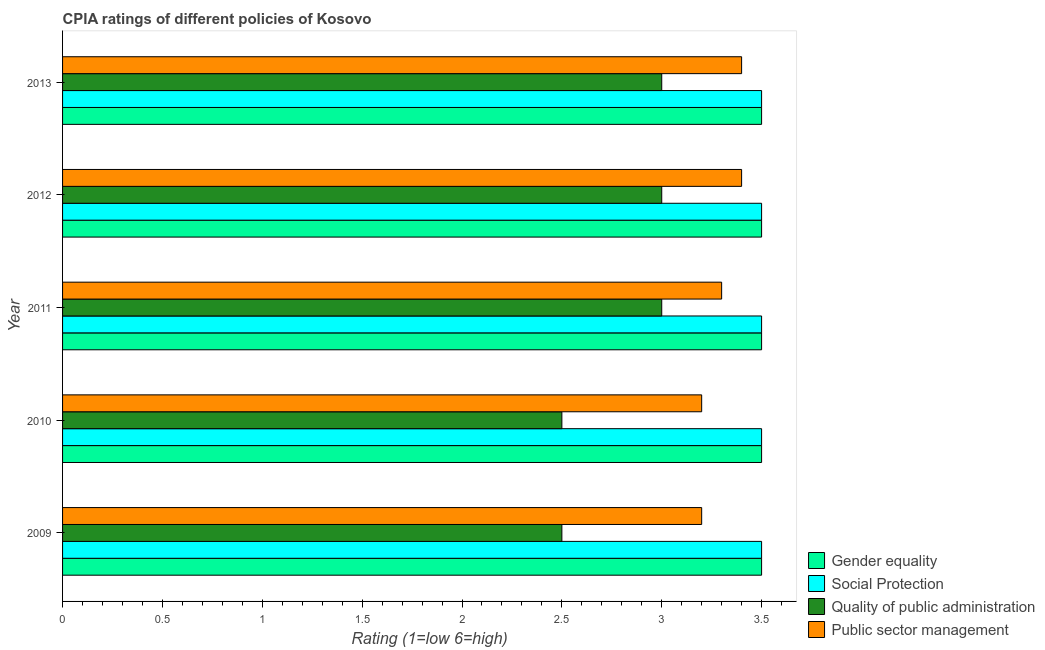How many different coloured bars are there?
Ensure brevity in your answer.  4. Are the number of bars on each tick of the Y-axis equal?
Offer a very short reply. Yes. How many bars are there on the 2nd tick from the top?
Make the answer very short. 4. What is the label of the 1st group of bars from the top?
Offer a very short reply. 2013. In how many cases, is the number of bars for a given year not equal to the number of legend labels?
Give a very brief answer. 0. In which year was the cpia rating of public sector management maximum?
Your answer should be compact. 2012. In which year was the cpia rating of gender equality minimum?
Provide a succinct answer. 2009. What is the difference between the cpia rating of social protection in 2010 and that in 2012?
Offer a very short reply. 0. What is the difference between the cpia rating of public sector management in 2010 and the cpia rating of gender equality in 2011?
Your answer should be very brief. -0.3. In how many years, is the cpia rating of public sector management greater than 0.8 ?
Keep it short and to the point. 5. Is the cpia rating of social protection in 2010 less than that in 2011?
Provide a short and direct response. No. Is the difference between the cpia rating of public sector management in 2009 and 2013 greater than the difference between the cpia rating of quality of public administration in 2009 and 2013?
Your answer should be compact. Yes. What is the difference between the highest and the second highest cpia rating of public sector management?
Your answer should be compact. 0. What is the difference between the highest and the lowest cpia rating of quality of public administration?
Make the answer very short. 0.5. Is the sum of the cpia rating of quality of public administration in 2009 and 2013 greater than the maximum cpia rating of gender equality across all years?
Ensure brevity in your answer.  Yes. What does the 3rd bar from the top in 2011 represents?
Your answer should be very brief. Social Protection. What does the 1st bar from the bottom in 2011 represents?
Make the answer very short. Gender equality. How many bars are there?
Your response must be concise. 20. How many years are there in the graph?
Provide a short and direct response. 5. Does the graph contain any zero values?
Give a very brief answer. No. How are the legend labels stacked?
Your response must be concise. Vertical. What is the title of the graph?
Your answer should be very brief. CPIA ratings of different policies of Kosovo. Does "Korea" appear as one of the legend labels in the graph?
Your answer should be very brief. No. What is the label or title of the X-axis?
Provide a succinct answer. Rating (1=low 6=high). What is the label or title of the Y-axis?
Offer a terse response. Year. What is the Rating (1=low 6=high) in Quality of public administration in 2009?
Make the answer very short. 2.5. What is the Rating (1=low 6=high) in Public sector management in 2009?
Your answer should be very brief. 3.2. What is the Rating (1=low 6=high) of Gender equality in 2010?
Provide a succinct answer. 3.5. What is the Rating (1=low 6=high) in Social Protection in 2010?
Your answer should be very brief. 3.5. What is the Rating (1=low 6=high) in Quality of public administration in 2010?
Your answer should be compact. 2.5. What is the Rating (1=low 6=high) in Public sector management in 2011?
Your answer should be very brief. 3.3. What is the Rating (1=low 6=high) in Social Protection in 2012?
Make the answer very short. 3.5. What is the Rating (1=low 6=high) of Gender equality in 2013?
Provide a succinct answer. 3.5. What is the Rating (1=low 6=high) of Quality of public administration in 2013?
Keep it short and to the point. 3. Across all years, what is the maximum Rating (1=low 6=high) of Social Protection?
Your response must be concise. 3.5. Across all years, what is the minimum Rating (1=low 6=high) in Gender equality?
Your answer should be compact. 3.5. Across all years, what is the minimum Rating (1=low 6=high) of Social Protection?
Your answer should be very brief. 3.5. What is the total Rating (1=low 6=high) in Gender equality in the graph?
Keep it short and to the point. 17.5. What is the total Rating (1=low 6=high) in Quality of public administration in the graph?
Your response must be concise. 14. What is the total Rating (1=low 6=high) in Public sector management in the graph?
Ensure brevity in your answer.  16.5. What is the difference between the Rating (1=low 6=high) of Social Protection in 2009 and that in 2010?
Offer a very short reply. 0. What is the difference between the Rating (1=low 6=high) in Gender equality in 2009 and that in 2011?
Keep it short and to the point. 0. What is the difference between the Rating (1=low 6=high) in Social Protection in 2009 and that in 2011?
Your answer should be very brief. 0. What is the difference between the Rating (1=low 6=high) of Quality of public administration in 2009 and that in 2011?
Offer a very short reply. -0.5. What is the difference between the Rating (1=low 6=high) of Public sector management in 2009 and that in 2011?
Keep it short and to the point. -0.1. What is the difference between the Rating (1=low 6=high) in Gender equality in 2009 and that in 2013?
Keep it short and to the point. 0. What is the difference between the Rating (1=low 6=high) in Social Protection in 2009 and that in 2013?
Give a very brief answer. 0. What is the difference between the Rating (1=low 6=high) of Quality of public administration in 2009 and that in 2013?
Your response must be concise. -0.5. What is the difference between the Rating (1=low 6=high) of Public sector management in 2009 and that in 2013?
Offer a very short reply. -0.2. What is the difference between the Rating (1=low 6=high) in Gender equality in 2010 and that in 2011?
Offer a terse response. 0. What is the difference between the Rating (1=low 6=high) in Social Protection in 2010 and that in 2011?
Your answer should be compact. 0. What is the difference between the Rating (1=low 6=high) of Quality of public administration in 2010 and that in 2011?
Your answer should be very brief. -0.5. What is the difference between the Rating (1=low 6=high) of Social Protection in 2010 and that in 2012?
Your response must be concise. 0. What is the difference between the Rating (1=low 6=high) of Public sector management in 2010 and that in 2012?
Your answer should be very brief. -0.2. What is the difference between the Rating (1=low 6=high) in Social Protection in 2010 and that in 2013?
Your answer should be compact. 0. What is the difference between the Rating (1=low 6=high) of Public sector management in 2010 and that in 2013?
Your answer should be compact. -0.2. What is the difference between the Rating (1=low 6=high) in Gender equality in 2011 and that in 2013?
Make the answer very short. 0. What is the difference between the Rating (1=low 6=high) of Public sector management in 2011 and that in 2013?
Your answer should be compact. -0.1. What is the difference between the Rating (1=low 6=high) in Social Protection in 2012 and that in 2013?
Ensure brevity in your answer.  0. What is the difference between the Rating (1=low 6=high) of Quality of public administration in 2012 and that in 2013?
Ensure brevity in your answer.  0. What is the difference between the Rating (1=low 6=high) of Gender equality in 2009 and the Rating (1=low 6=high) of Social Protection in 2010?
Your answer should be very brief. 0. What is the difference between the Rating (1=low 6=high) of Gender equality in 2009 and the Rating (1=low 6=high) of Quality of public administration in 2010?
Make the answer very short. 1. What is the difference between the Rating (1=low 6=high) of Quality of public administration in 2009 and the Rating (1=low 6=high) of Public sector management in 2010?
Provide a succinct answer. -0.7. What is the difference between the Rating (1=low 6=high) of Gender equality in 2009 and the Rating (1=low 6=high) of Social Protection in 2011?
Offer a terse response. 0. What is the difference between the Rating (1=low 6=high) of Gender equality in 2009 and the Rating (1=low 6=high) of Public sector management in 2011?
Ensure brevity in your answer.  0.2. What is the difference between the Rating (1=low 6=high) of Social Protection in 2009 and the Rating (1=low 6=high) of Quality of public administration in 2011?
Provide a succinct answer. 0.5. What is the difference between the Rating (1=low 6=high) in Social Protection in 2009 and the Rating (1=low 6=high) in Public sector management in 2011?
Ensure brevity in your answer.  0.2. What is the difference between the Rating (1=low 6=high) in Gender equality in 2009 and the Rating (1=low 6=high) in Quality of public administration in 2012?
Provide a short and direct response. 0.5. What is the difference between the Rating (1=low 6=high) in Social Protection in 2009 and the Rating (1=low 6=high) in Quality of public administration in 2012?
Your answer should be very brief. 0.5. What is the difference between the Rating (1=low 6=high) of Quality of public administration in 2009 and the Rating (1=low 6=high) of Public sector management in 2012?
Your response must be concise. -0.9. What is the difference between the Rating (1=low 6=high) of Gender equality in 2009 and the Rating (1=low 6=high) of Social Protection in 2013?
Offer a terse response. 0. What is the difference between the Rating (1=low 6=high) of Gender equality in 2009 and the Rating (1=low 6=high) of Quality of public administration in 2013?
Your answer should be very brief. 0.5. What is the difference between the Rating (1=low 6=high) of Social Protection in 2009 and the Rating (1=low 6=high) of Quality of public administration in 2013?
Give a very brief answer. 0.5. What is the difference between the Rating (1=low 6=high) of Quality of public administration in 2009 and the Rating (1=low 6=high) of Public sector management in 2013?
Provide a succinct answer. -0.9. What is the difference between the Rating (1=low 6=high) of Gender equality in 2010 and the Rating (1=low 6=high) of Quality of public administration in 2011?
Give a very brief answer. 0.5. What is the difference between the Rating (1=low 6=high) in Social Protection in 2010 and the Rating (1=low 6=high) in Quality of public administration in 2011?
Provide a short and direct response. 0.5. What is the difference between the Rating (1=low 6=high) of Social Protection in 2010 and the Rating (1=low 6=high) of Public sector management in 2011?
Ensure brevity in your answer.  0.2. What is the difference between the Rating (1=low 6=high) in Quality of public administration in 2010 and the Rating (1=low 6=high) in Public sector management in 2011?
Provide a short and direct response. -0.8. What is the difference between the Rating (1=low 6=high) in Social Protection in 2010 and the Rating (1=low 6=high) in Quality of public administration in 2012?
Offer a terse response. 0.5. What is the difference between the Rating (1=low 6=high) in Social Protection in 2010 and the Rating (1=low 6=high) in Public sector management in 2012?
Provide a short and direct response. 0.1. What is the difference between the Rating (1=low 6=high) of Gender equality in 2010 and the Rating (1=low 6=high) of Quality of public administration in 2013?
Keep it short and to the point. 0.5. What is the difference between the Rating (1=low 6=high) in Gender equality in 2010 and the Rating (1=low 6=high) in Public sector management in 2013?
Provide a short and direct response. 0.1. What is the difference between the Rating (1=low 6=high) of Social Protection in 2010 and the Rating (1=low 6=high) of Quality of public administration in 2013?
Keep it short and to the point. 0.5. What is the difference between the Rating (1=low 6=high) in Quality of public administration in 2010 and the Rating (1=low 6=high) in Public sector management in 2013?
Your answer should be very brief. -0.9. What is the difference between the Rating (1=low 6=high) in Gender equality in 2011 and the Rating (1=low 6=high) in Quality of public administration in 2012?
Offer a very short reply. 0.5. What is the difference between the Rating (1=low 6=high) of Gender equality in 2011 and the Rating (1=low 6=high) of Public sector management in 2012?
Your response must be concise. 0.1. What is the difference between the Rating (1=low 6=high) in Social Protection in 2011 and the Rating (1=low 6=high) in Quality of public administration in 2012?
Provide a succinct answer. 0.5. What is the difference between the Rating (1=low 6=high) of Gender equality in 2011 and the Rating (1=low 6=high) of Social Protection in 2013?
Offer a very short reply. 0. What is the difference between the Rating (1=low 6=high) in Gender equality in 2011 and the Rating (1=low 6=high) in Quality of public administration in 2013?
Offer a very short reply. 0.5. What is the difference between the Rating (1=low 6=high) of Gender equality in 2011 and the Rating (1=low 6=high) of Public sector management in 2013?
Make the answer very short. 0.1. What is the difference between the Rating (1=low 6=high) of Social Protection in 2011 and the Rating (1=low 6=high) of Quality of public administration in 2013?
Provide a short and direct response. 0.5. What is the difference between the Rating (1=low 6=high) of Gender equality in 2012 and the Rating (1=low 6=high) of Social Protection in 2013?
Provide a succinct answer. 0. What is the difference between the Rating (1=low 6=high) of Gender equality in 2012 and the Rating (1=low 6=high) of Quality of public administration in 2013?
Your response must be concise. 0.5. What is the difference between the Rating (1=low 6=high) of Gender equality in 2012 and the Rating (1=low 6=high) of Public sector management in 2013?
Your answer should be compact. 0.1. What is the difference between the Rating (1=low 6=high) in Social Protection in 2012 and the Rating (1=low 6=high) in Quality of public administration in 2013?
Keep it short and to the point. 0.5. What is the difference between the Rating (1=low 6=high) of Quality of public administration in 2012 and the Rating (1=low 6=high) of Public sector management in 2013?
Provide a succinct answer. -0.4. What is the average Rating (1=low 6=high) of Quality of public administration per year?
Keep it short and to the point. 2.8. In the year 2009, what is the difference between the Rating (1=low 6=high) in Gender equality and Rating (1=low 6=high) in Social Protection?
Give a very brief answer. 0. In the year 2009, what is the difference between the Rating (1=low 6=high) of Gender equality and Rating (1=low 6=high) of Quality of public administration?
Provide a short and direct response. 1. In the year 2009, what is the difference between the Rating (1=low 6=high) in Gender equality and Rating (1=low 6=high) in Public sector management?
Keep it short and to the point. 0.3. In the year 2009, what is the difference between the Rating (1=low 6=high) in Social Protection and Rating (1=low 6=high) in Public sector management?
Provide a succinct answer. 0.3. In the year 2010, what is the difference between the Rating (1=low 6=high) in Gender equality and Rating (1=low 6=high) in Quality of public administration?
Your response must be concise. 1. In the year 2010, what is the difference between the Rating (1=low 6=high) of Gender equality and Rating (1=low 6=high) of Public sector management?
Provide a succinct answer. 0.3. In the year 2010, what is the difference between the Rating (1=low 6=high) in Social Protection and Rating (1=low 6=high) in Quality of public administration?
Provide a short and direct response. 1. In the year 2010, what is the difference between the Rating (1=low 6=high) in Social Protection and Rating (1=low 6=high) in Public sector management?
Offer a terse response. 0.3. In the year 2010, what is the difference between the Rating (1=low 6=high) in Quality of public administration and Rating (1=low 6=high) in Public sector management?
Offer a very short reply. -0.7. In the year 2011, what is the difference between the Rating (1=low 6=high) of Gender equality and Rating (1=low 6=high) of Social Protection?
Your answer should be very brief. 0. In the year 2011, what is the difference between the Rating (1=low 6=high) of Quality of public administration and Rating (1=low 6=high) of Public sector management?
Keep it short and to the point. -0.3. In the year 2012, what is the difference between the Rating (1=low 6=high) in Gender equality and Rating (1=low 6=high) in Social Protection?
Your answer should be very brief. 0. In the year 2012, what is the difference between the Rating (1=low 6=high) of Gender equality and Rating (1=low 6=high) of Public sector management?
Give a very brief answer. 0.1. In the year 2012, what is the difference between the Rating (1=low 6=high) of Social Protection and Rating (1=low 6=high) of Quality of public administration?
Your answer should be compact. 0.5. In the year 2012, what is the difference between the Rating (1=low 6=high) of Social Protection and Rating (1=low 6=high) of Public sector management?
Make the answer very short. 0.1. In the year 2012, what is the difference between the Rating (1=low 6=high) of Quality of public administration and Rating (1=low 6=high) of Public sector management?
Provide a short and direct response. -0.4. In the year 2013, what is the difference between the Rating (1=low 6=high) of Gender equality and Rating (1=low 6=high) of Social Protection?
Ensure brevity in your answer.  0. In the year 2013, what is the difference between the Rating (1=low 6=high) in Gender equality and Rating (1=low 6=high) in Public sector management?
Make the answer very short. 0.1. In the year 2013, what is the difference between the Rating (1=low 6=high) in Social Protection and Rating (1=low 6=high) in Quality of public administration?
Give a very brief answer. 0.5. What is the ratio of the Rating (1=low 6=high) in Gender equality in 2009 to that in 2010?
Offer a very short reply. 1. What is the ratio of the Rating (1=low 6=high) in Social Protection in 2009 to that in 2010?
Provide a succinct answer. 1. What is the ratio of the Rating (1=low 6=high) in Quality of public administration in 2009 to that in 2011?
Your answer should be very brief. 0.83. What is the ratio of the Rating (1=low 6=high) of Public sector management in 2009 to that in 2011?
Keep it short and to the point. 0.97. What is the ratio of the Rating (1=low 6=high) in Gender equality in 2009 to that in 2012?
Provide a succinct answer. 1. What is the ratio of the Rating (1=low 6=high) of Social Protection in 2009 to that in 2012?
Give a very brief answer. 1. What is the ratio of the Rating (1=low 6=high) of Quality of public administration in 2009 to that in 2012?
Provide a short and direct response. 0.83. What is the ratio of the Rating (1=low 6=high) of Public sector management in 2009 to that in 2012?
Your response must be concise. 0.94. What is the ratio of the Rating (1=low 6=high) of Social Protection in 2009 to that in 2013?
Provide a short and direct response. 1. What is the ratio of the Rating (1=low 6=high) in Quality of public administration in 2009 to that in 2013?
Make the answer very short. 0.83. What is the ratio of the Rating (1=low 6=high) of Social Protection in 2010 to that in 2011?
Your response must be concise. 1. What is the ratio of the Rating (1=low 6=high) of Quality of public administration in 2010 to that in 2011?
Offer a terse response. 0.83. What is the ratio of the Rating (1=low 6=high) of Public sector management in 2010 to that in 2011?
Keep it short and to the point. 0.97. What is the ratio of the Rating (1=low 6=high) in Gender equality in 2010 to that in 2012?
Keep it short and to the point. 1. What is the ratio of the Rating (1=low 6=high) of Quality of public administration in 2010 to that in 2012?
Provide a succinct answer. 0.83. What is the ratio of the Rating (1=low 6=high) of Quality of public administration in 2010 to that in 2013?
Your response must be concise. 0.83. What is the ratio of the Rating (1=low 6=high) in Public sector management in 2010 to that in 2013?
Offer a very short reply. 0.94. What is the ratio of the Rating (1=low 6=high) in Gender equality in 2011 to that in 2012?
Provide a short and direct response. 1. What is the ratio of the Rating (1=low 6=high) of Public sector management in 2011 to that in 2012?
Your answer should be very brief. 0.97. What is the ratio of the Rating (1=low 6=high) of Gender equality in 2011 to that in 2013?
Your answer should be very brief. 1. What is the ratio of the Rating (1=low 6=high) of Social Protection in 2011 to that in 2013?
Give a very brief answer. 1. What is the ratio of the Rating (1=low 6=high) in Quality of public administration in 2011 to that in 2013?
Give a very brief answer. 1. What is the ratio of the Rating (1=low 6=high) in Public sector management in 2011 to that in 2013?
Your response must be concise. 0.97. What is the ratio of the Rating (1=low 6=high) in Gender equality in 2012 to that in 2013?
Your answer should be compact. 1. What is the difference between the highest and the second highest Rating (1=low 6=high) in Gender equality?
Give a very brief answer. 0. What is the difference between the highest and the second highest Rating (1=low 6=high) of Social Protection?
Keep it short and to the point. 0. What is the difference between the highest and the lowest Rating (1=low 6=high) in Gender equality?
Your response must be concise. 0. What is the difference between the highest and the lowest Rating (1=low 6=high) in Social Protection?
Offer a very short reply. 0. What is the difference between the highest and the lowest Rating (1=low 6=high) of Public sector management?
Give a very brief answer. 0.2. 